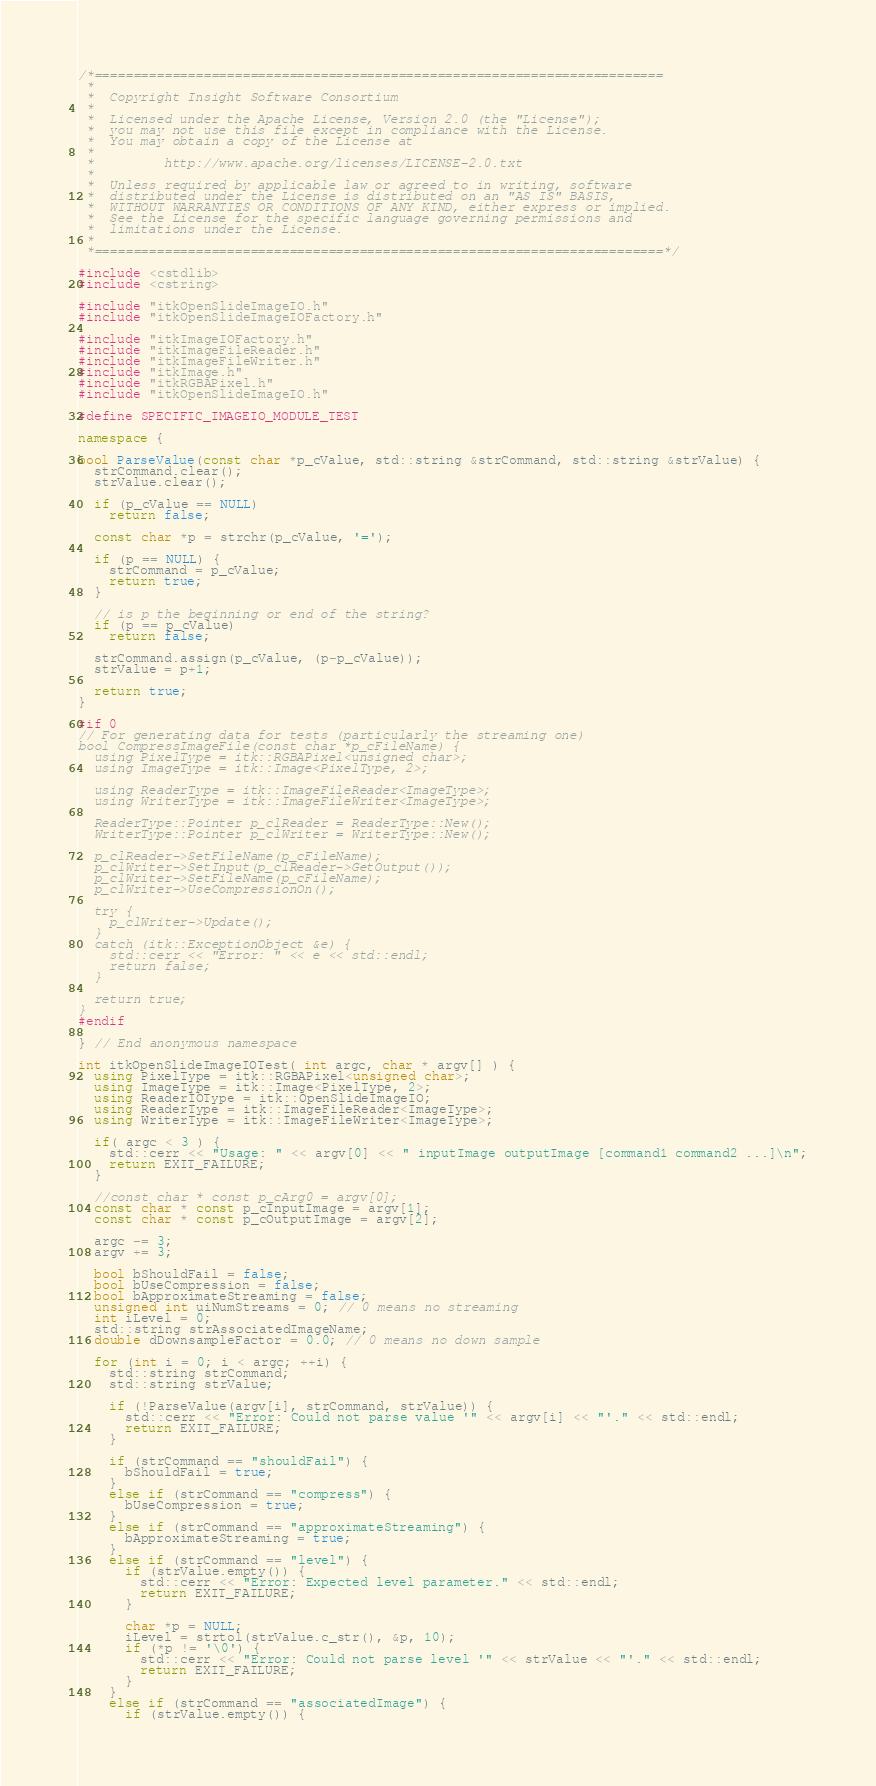<code> <loc_0><loc_0><loc_500><loc_500><_C++_>/*=========================================================================
 *
 *  Copyright Insight Software Consortium
 *
 *  Licensed under the Apache License, Version 2.0 (the "License");
 *  you may not use this file except in compliance with the License.
 *  You may obtain a copy of the License at
 *
 *         http://www.apache.org/licenses/LICENSE-2.0.txt
 *
 *  Unless required by applicable law or agreed to in writing, software
 *  distributed under the License is distributed on an "AS IS" BASIS,
 *  WITHOUT WARRANTIES OR CONDITIONS OF ANY KIND, either express or implied.
 *  See the License for the specific language governing permissions and
 *  limitations under the License.
 *
 *=========================================================================*/

#include <cstdlib>
#include <cstring>

#include "itkOpenSlideImageIO.h"
#include "itkOpenSlideImageIOFactory.h"

#include "itkImageIOFactory.h"
#include "itkImageFileReader.h"
#include "itkImageFileWriter.h"
#include "itkImage.h"
#include "itkRGBAPixel.h"
#include "itkOpenSlideImageIO.h"

#define SPECIFIC_IMAGEIO_MODULE_TEST

namespace {

bool ParseValue(const char *p_cValue, std::string &strCommand, std::string &strValue) {
  strCommand.clear();
  strValue.clear();

  if (p_cValue == NULL)
    return false;

  const char *p = strchr(p_cValue, '=');

  if (p == NULL) {
    strCommand = p_cValue;
    return true;
  }

  // is p the beginning or end of the string?
  if (p == p_cValue)
    return false;

  strCommand.assign(p_cValue, (p-p_cValue));
  strValue = p+1;

  return true;
}

#if 0
// For generating data for tests (particularly the streaming one)
bool CompressImageFile(const char *p_cFileName) {
  using PixelType = itk::RGBAPixel<unsigned char>;
  using ImageType = itk::Image<PixelType, 2>;

  using ReaderType = itk::ImageFileReader<ImageType>;
  using WriterType = itk::ImageFileWriter<ImageType>;

  ReaderType::Pointer p_clReader = ReaderType::New();
  WriterType::Pointer p_clWriter = WriterType::New();

  p_clReader->SetFileName(p_cFileName);
  p_clWriter->SetInput(p_clReader->GetOutput());
  p_clWriter->SetFileName(p_cFileName);
  p_clWriter->UseCompressionOn();

  try {
    p_clWriter->Update();
  }
  catch (itk::ExceptionObject &e) {
    std::cerr << "Error: " << e << std::endl;
    return false;
  }

  return true;
}
#endif

} // End anonymous namespace

int itkOpenSlideImageIOTest( int argc, char * argv[] ) {
  using PixelType = itk::RGBAPixel<unsigned char>;
  using ImageType = itk::Image<PixelType, 2>;
  using ReaderIOType = itk::OpenSlideImageIO;
  using ReaderType = itk::ImageFileReader<ImageType>;
  using WriterType = itk::ImageFileWriter<ImageType>;

  if( argc < 3 ) {
    std::cerr << "Usage: " << argv[0] << " inputImage outputImage [command1 command2 ...]\n";
    return EXIT_FAILURE;
  }

  //const char * const p_cArg0 = argv[0];
  const char * const p_cInputImage = argv[1];
  const char * const p_cOutputImage = argv[2];

  argc -= 3;
  argv += 3;

  bool bShouldFail = false;
  bool bUseCompression = false;
  bool bApproximateStreaming = false;
  unsigned int uiNumStreams = 0; // 0 means no streaming
  int iLevel = 0;
  std::string strAssociatedImageName;
  double dDownsampleFactor = 0.0; // 0 means no down sample

  for (int i = 0; i < argc; ++i) {
    std::string strCommand;
    std::string strValue;

    if (!ParseValue(argv[i], strCommand, strValue)) {
      std::cerr << "Error: Could not parse value '" << argv[i] << "'." << std::endl;
      return EXIT_FAILURE;
    }

    if (strCommand == "shouldFail") {
      bShouldFail = true;
    }
    else if (strCommand == "compress") {
      bUseCompression = true;
    }
    else if (strCommand == "approximateStreaming") {
      bApproximateStreaming = true;
    }
    else if (strCommand == "level") {
      if (strValue.empty()) {
        std::cerr << "Error: Expected level parameter." << std::endl;
        return EXIT_FAILURE;
      }

      char *p = NULL;
      iLevel = strtol(strValue.c_str(), &p, 10);
      if (*p != '\0') {
        std::cerr << "Error: Could not parse level '" << strValue << "'." << std::endl;
        return EXIT_FAILURE;
      }
    }
    else if (strCommand == "associatedImage") {
      if (strValue.empty()) {</code> 